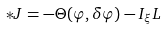Convert formula to latex. <formula><loc_0><loc_0><loc_500><loc_500>\ast J = - \Theta ( \varphi , \delta \varphi ) - I _ { \xi } L</formula> 